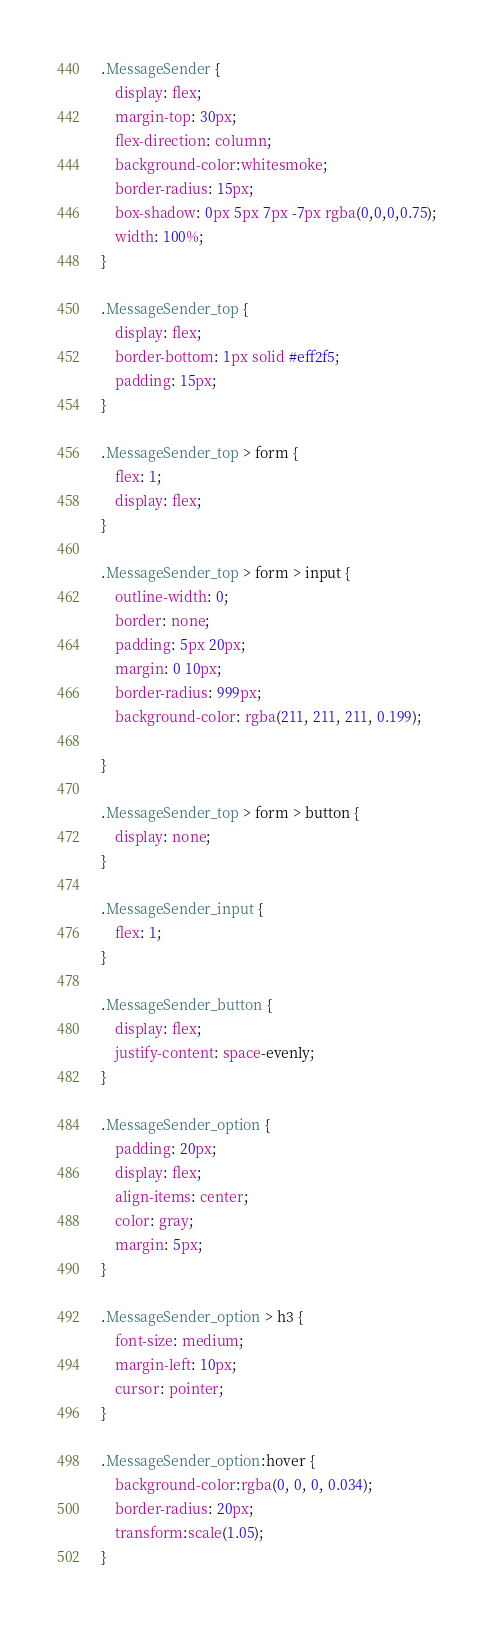<code> <loc_0><loc_0><loc_500><loc_500><_CSS_>.MessageSender {
    display: flex;
    margin-top: 30px;
    flex-direction: column;
    background-color:whitesmoke;
    border-radius: 15px;
    box-shadow: 0px 5px 7px -7px rgba(0,0,0,0.75);
    width: 100%;
}

.MessageSender_top {
    display: flex;
    border-bottom: 1px solid #eff2f5;
    padding: 15px;
}

.MessageSender_top > form {
    flex: 1;
    display: flex;
}

.MessageSender_top > form > input {
    outline-width: 0;
    border: none;
    padding: 5px 20px;
    margin: 0 10px;
    border-radius: 999px;
    background-color: rgba(211, 211, 211, 0.199);
    
}

.MessageSender_top > form > button {
    display: none;
}

.MessageSender_input {
    flex: 1;
}

.MessageSender_button {
    display: flex;
    justify-content: space-evenly;
}

.MessageSender_option {
    padding: 20px;
    display: flex;
    align-items: center;
    color: gray;
    margin: 5px;
}

.MessageSender_option > h3 {
    font-size: medium;
    margin-left: 10px;
    cursor: pointer;
}

.MessageSender_option:hover {
    background-color:rgba(0, 0, 0, 0.034);
    border-radius: 20px;
    transform:scale(1.05);
}


</code> 